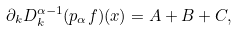<formula> <loc_0><loc_0><loc_500><loc_500>\partial _ { k } D _ { k } ^ { \alpha - 1 } ( p _ { \alpha } f ) ( x ) = A + B + C ,</formula> 